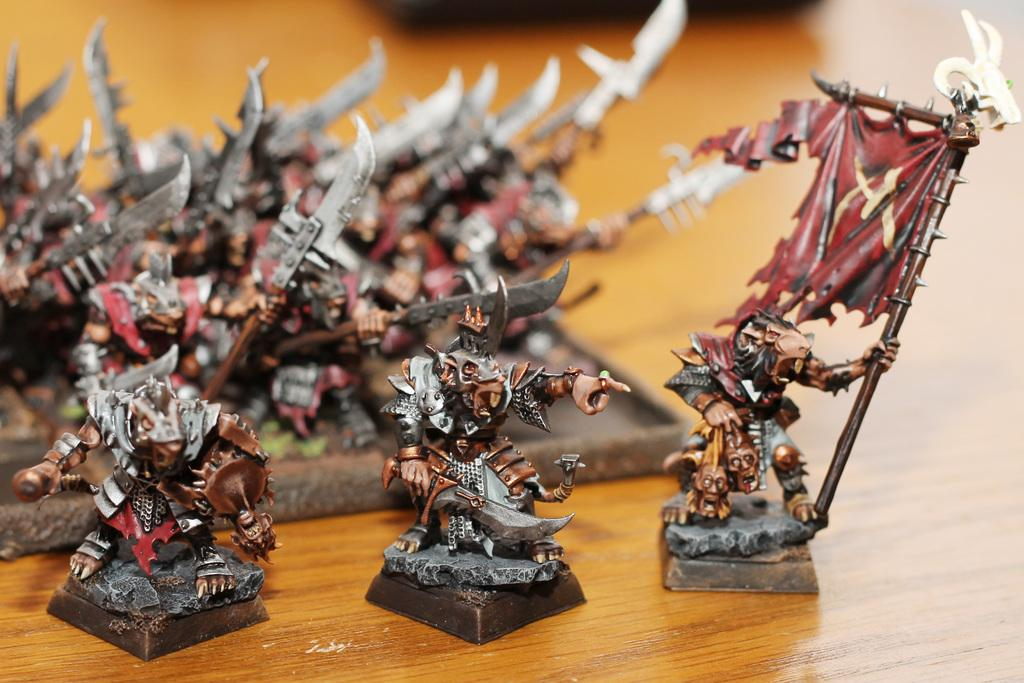What type of objects can be seen in the image? There are sculptures in the image. What is the material of the surface on which the sculptures are placed? The sculptures are placed on a wooden surface. What color is the shirt worn by the sculpture in the image? There are no sculptures wearing shirts in the image, as sculptures are not typically depicted wearing clothing. 